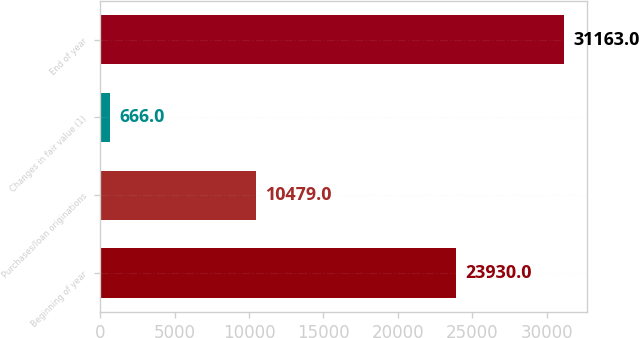Convert chart. <chart><loc_0><loc_0><loc_500><loc_500><bar_chart><fcel>Beginning of year<fcel>Purchases/loan originations<fcel>Changes in fair value (1)<fcel>End of year<nl><fcel>23930<fcel>10479<fcel>666<fcel>31163<nl></chart> 